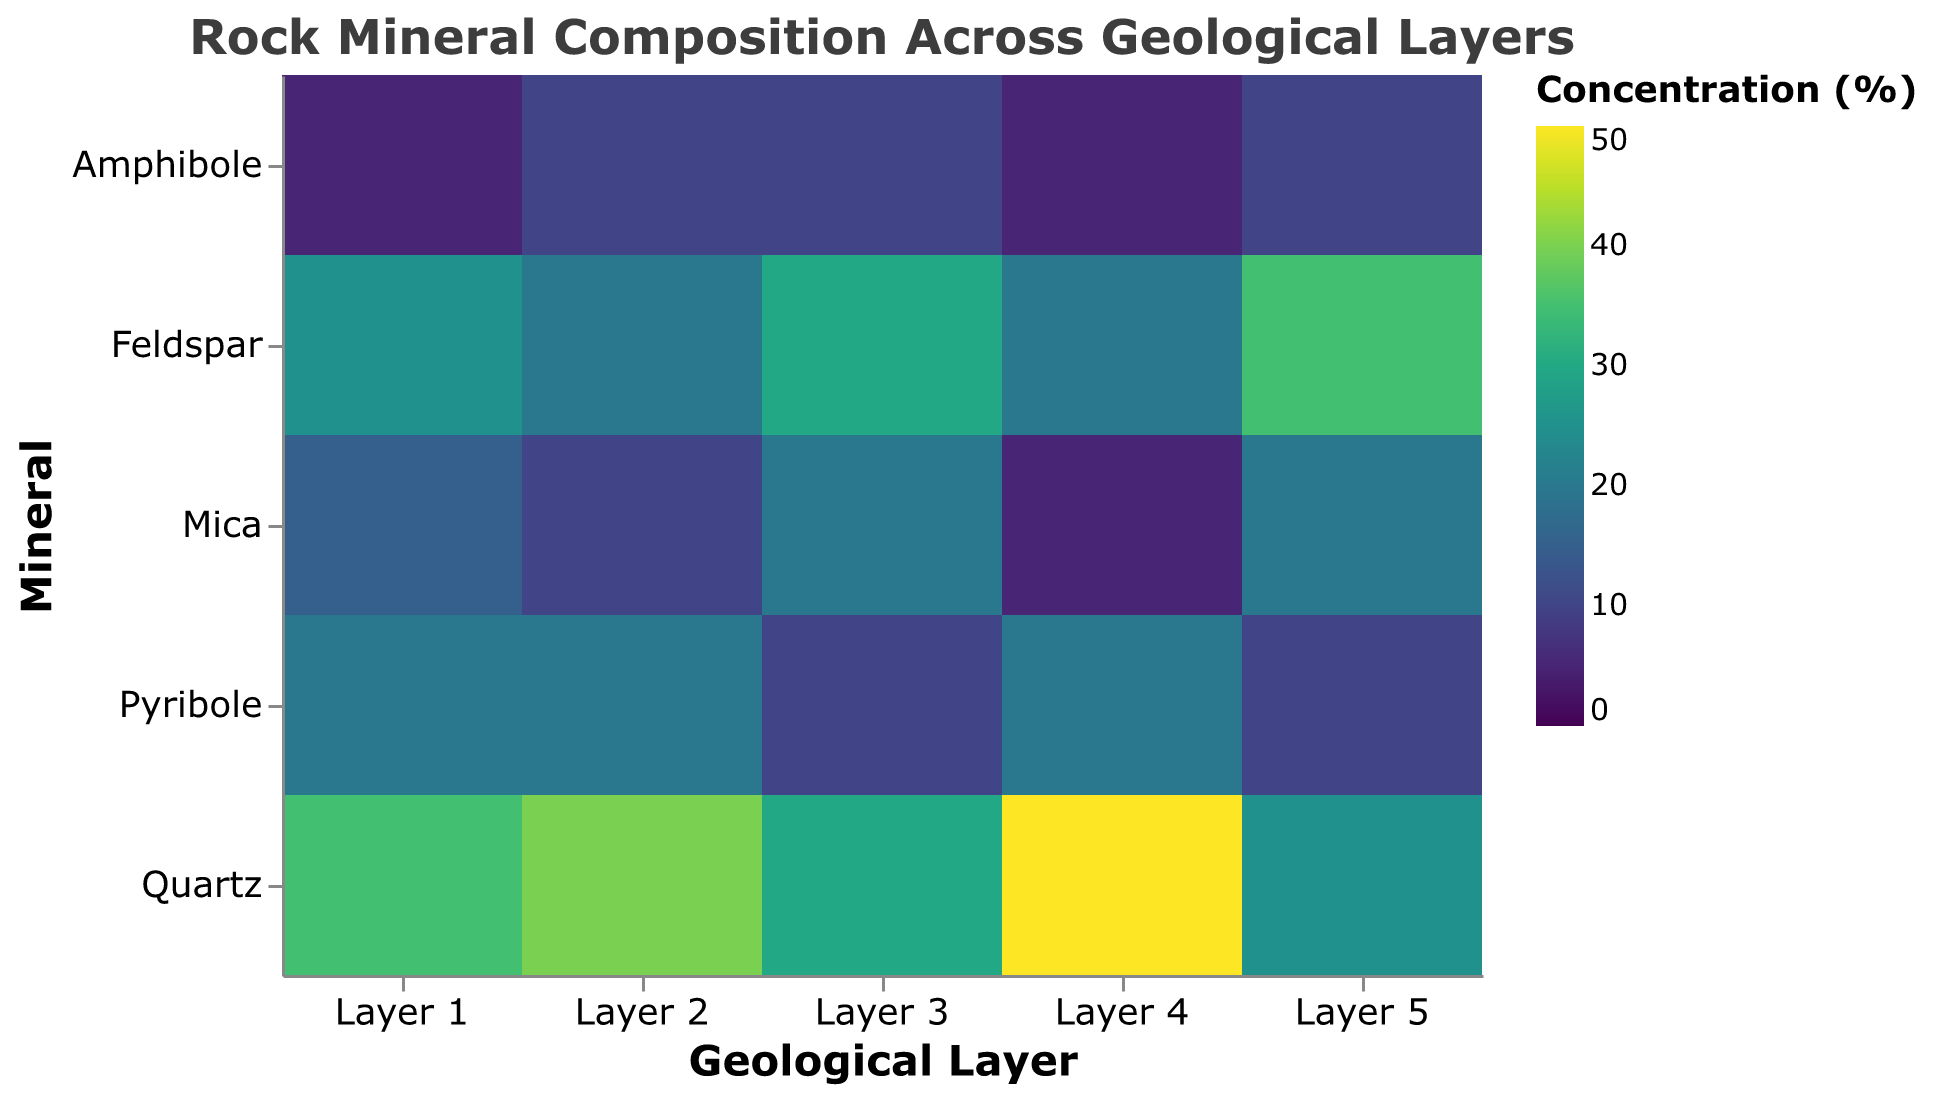What's the title of the heatmap? The title of the heatmap is found at the top of the figure and indicates the overall topic. In this heatmap, the title is "Rock Mineral Composition Across Geological Layers".
Answer: Rock Mineral Composition Across Geological Layers Which mineral has the highest concentration in Layer 4? In Layer 4, you can see the color intensity in the heatmap. Quartz has a concentration of 50%, which is the highest among the minerals in that layer.
Answer: Quartz What's the concentration of Mica in Layer 3? Look at the intersection of Layer 3 and Mica on the heatmap. The color and tooltip indicate the concentration. For Mica in Layer 3, the concentration is 20%.
Answer: 20% In which layer does Feldspar have the lowest concentration? By comparing the color intensity of Feldspar across all layers, Layer 2 has the lowest concentration of Feldspar at 20%.
Answer: Layer 2 What is the average concentration of Quartz across all layers? Sum the concentrations of Quartz in each layer (35 + 40 + 30 + 50 + 25 = 180) and divide by the number of layers (5). The average concentration is 180/5 = 36%.
Answer: 36% Compare the concentration of Amphibole between Layer 1 and Layer 5. Which is higher? Check the concentrations for Amphibole in Layer 1 (5%) and Layer 5 (10%). The concentration of Amphibole in Layer 5 is higher.
Answer: Layer 5 Is there any layer where the concentration of Pyribole is equal? Examine the concentrations of Pyribole across all layers. Pyribole’s concentration is 20% in Layers 1, 2, and 4.
Answer: Yes Which mineral shows the greatest variation in concentration across the layers? Calculate the range of concentrations for each mineral. Quartz ranges between 25% to 50%, showing the greatest variation of 25%.
Answer: Quartz What’s the most common concentration value for Pyribole across all the layers? By looking at the heatmap, Pyribole has a concentration of 20% in Layers 1, 2, and 4, which is the most common value.
Answer: 20% 